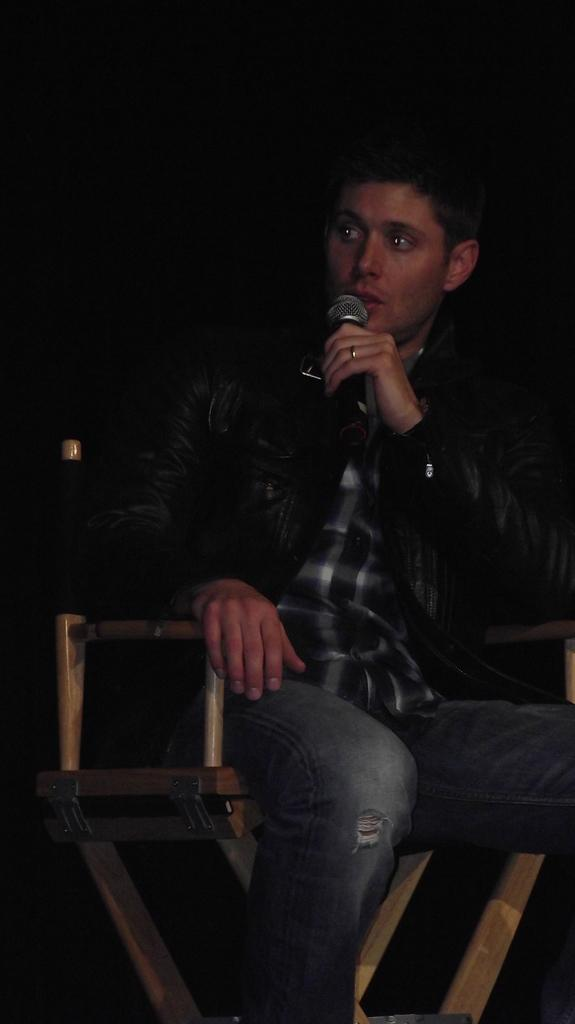Who is the main subject in the image? There is a man in the image. What is the man holding in his hand? The man is holding a mic with his hand. What is the man's posture in the image? The man is sitting on a chair. What is the color of the background in the image? The background of the image is dark. What type of glove is the man wearing in the image? There is no glove present in the image; the man is holding a mic with his hand. What is the man's journey to space like in the image? There is no mention of space or a journey in the image; it features a man sitting on a chair holding a mic. 